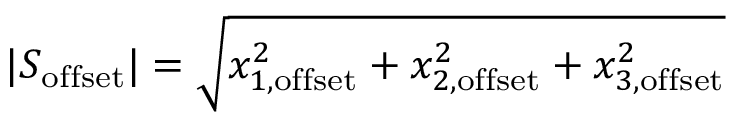Convert formula to latex. <formula><loc_0><loc_0><loc_500><loc_500>| S _ { o f f s e t } | = \sqrt { x _ { 1 , o f f s e t } ^ { 2 } + x _ { 2 , o f f s e t } ^ { 2 } + x _ { 3 , o f f s e t } ^ { 2 } }</formula> 